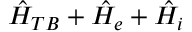<formula> <loc_0><loc_0><loc_500><loc_500>\hat { H } _ { T B } + \hat { H } _ { e } + \hat { H } _ { i }</formula> 